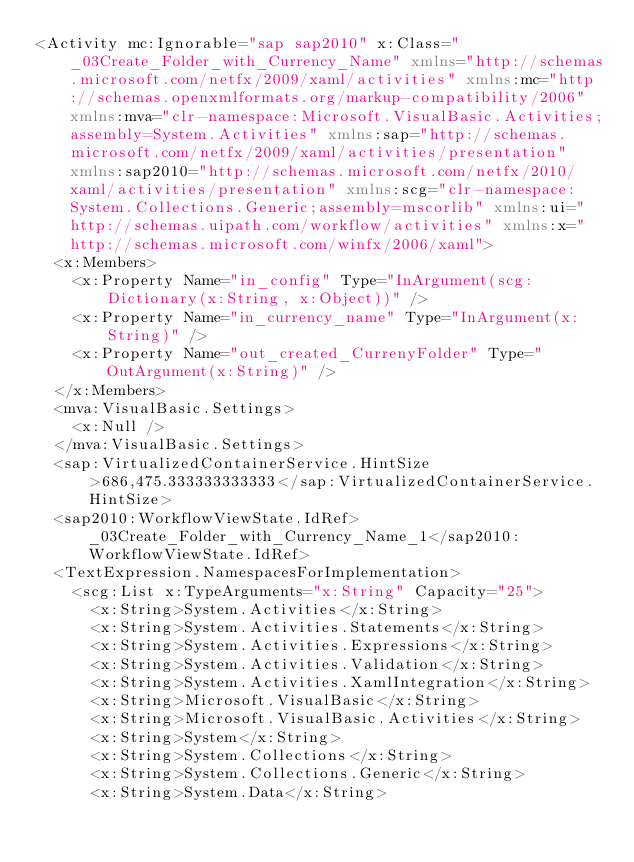<code> <loc_0><loc_0><loc_500><loc_500><_XML_><Activity mc:Ignorable="sap sap2010" x:Class="_03Create_Folder_with_Currency_Name" xmlns="http://schemas.microsoft.com/netfx/2009/xaml/activities" xmlns:mc="http://schemas.openxmlformats.org/markup-compatibility/2006" xmlns:mva="clr-namespace:Microsoft.VisualBasic.Activities;assembly=System.Activities" xmlns:sap="http://schemas.microsoft.com/netfx/2009/xaml/activities/presentation" xmlns:sap2010="http://schemas.microsoft.com/netfx/2010/xaml/activities/presentation" xmlns:scg="clr-namespace:System.Collections.Generic;assembly=mscorlib" xmlns:ui="http://schemas.uipath.com/workflow/activities" xmlns:x="http://schemas.microsoft.com/winfx/2006/xaml">
  <x:Members>
    <x:Property Name="in_config" Type="InArgument(scg:Dictionary(x:String, x:Object))" />
    <x:Property Name="in_currency_name" Type="InArgument(x:String)" />
    <x:Property Name="out_created_CurrenyFolder" Type="OutArgument(x:String)" />
  </x:Members>
  <mva:VisualBasic.Settings>
    <x:Null />
  </mva:VisualBasic.Settings>
  <sap:VirtualizedContainerService.HintSize>686,475.333333333333</sap:VirtualizedContainerService.HintSize>
  <sap2010:WorkflowViewState.IdRef>_03Create_Folder_with_Currency_Name_1</sap2010:WorkflowViewState.IdRef>
  <TextExpression.NamespacesForImplementation>
    <scg:List x:TypeArguments="x:String" Capacity="25">
      <x:String>System.Activities</x:String>
      <x:String>System.Activities.Statements</x:String>
      <x:String>System.Activities.Expressions</x:String>
      <x:String>System.Activities.Validation</x:String>
      <x:String>System.Activities.XamlIntegration</x:String>
      <x:String>Microsoft.VisualBasic</x:String>
      <x:String>Microsoft.VisualBasic.Activities</x:String>
      <x:String>System</x:String>
      <x:String>System.Collections</x:String>
      <x:String>System.Collections.Generic</x:String>
      <x:String>System.Data</x:String></code> 